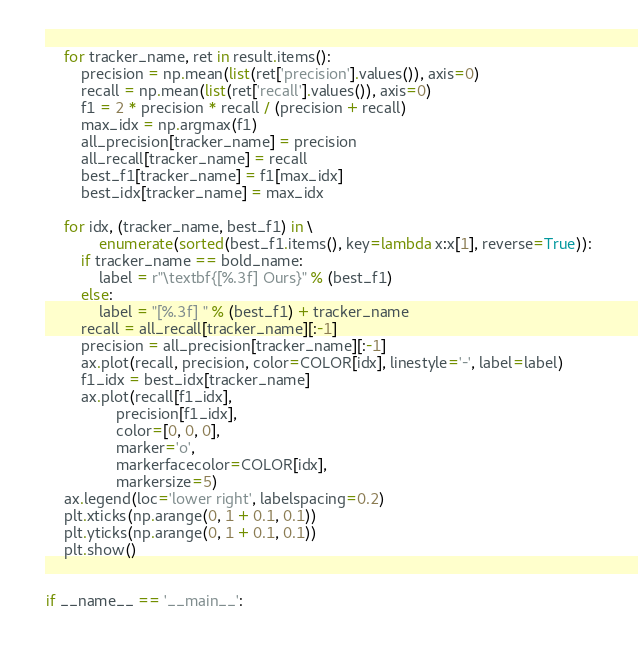<code> <loc_0><loc_0><loc_500><loc_500><_Python_>    for tracker_name, ret in result.items():
        precision = np.mean(list(ret['precision'].values()), axis=0)
        recall = np.mean(list(ret['recall'].values()), axis=0)
        f1 = 2 * precision * recall / (precision + recall)
        max_idx = np.argmax(f1)
        all_precision[tracker_name] = precision
        all_recall[tracker_name] = recall
        best_f1[tracker_name] = f1[max_idx]
        best_idx[tracker_name] = max_idx

    for idx, (tracker_name, best_f1) in \
            enumerate(sorted(best_f1.items(), key=lambda x:x[1], reverse=True)):
        if tracker_name == bold_name:
            label = r"\textbf{[%.3f] Ours}" % (best_f1)
        else:
            label = "[%.3f] " % (best_f1) + tracker_name
        recall = all_recall[tracker_name][:-1]
        precision = all_precision[tracker_name][:-1]
        ax.plot(recall, precision, color=COLOR[idx], linestyle='-', label=label)
        f1_idx = best_idx[tracker_name]
        ax.plot(recall[f1_idx],
                precision[f1_idx],
                color=[0, 0, 0],
                marker='o',
                markerfacecolor=COLOR[idx],
                markersize=5)
    ax.legend(loc='lower right', labelspacing=0.2)
    plt.xticks(np.arange(0, 1 + 0.1, 0.1))
    plt.yticks(np.arange(0, 1 + 0.1, 0.1))
    plt.show()


if __name__ == '__main__':</code> 